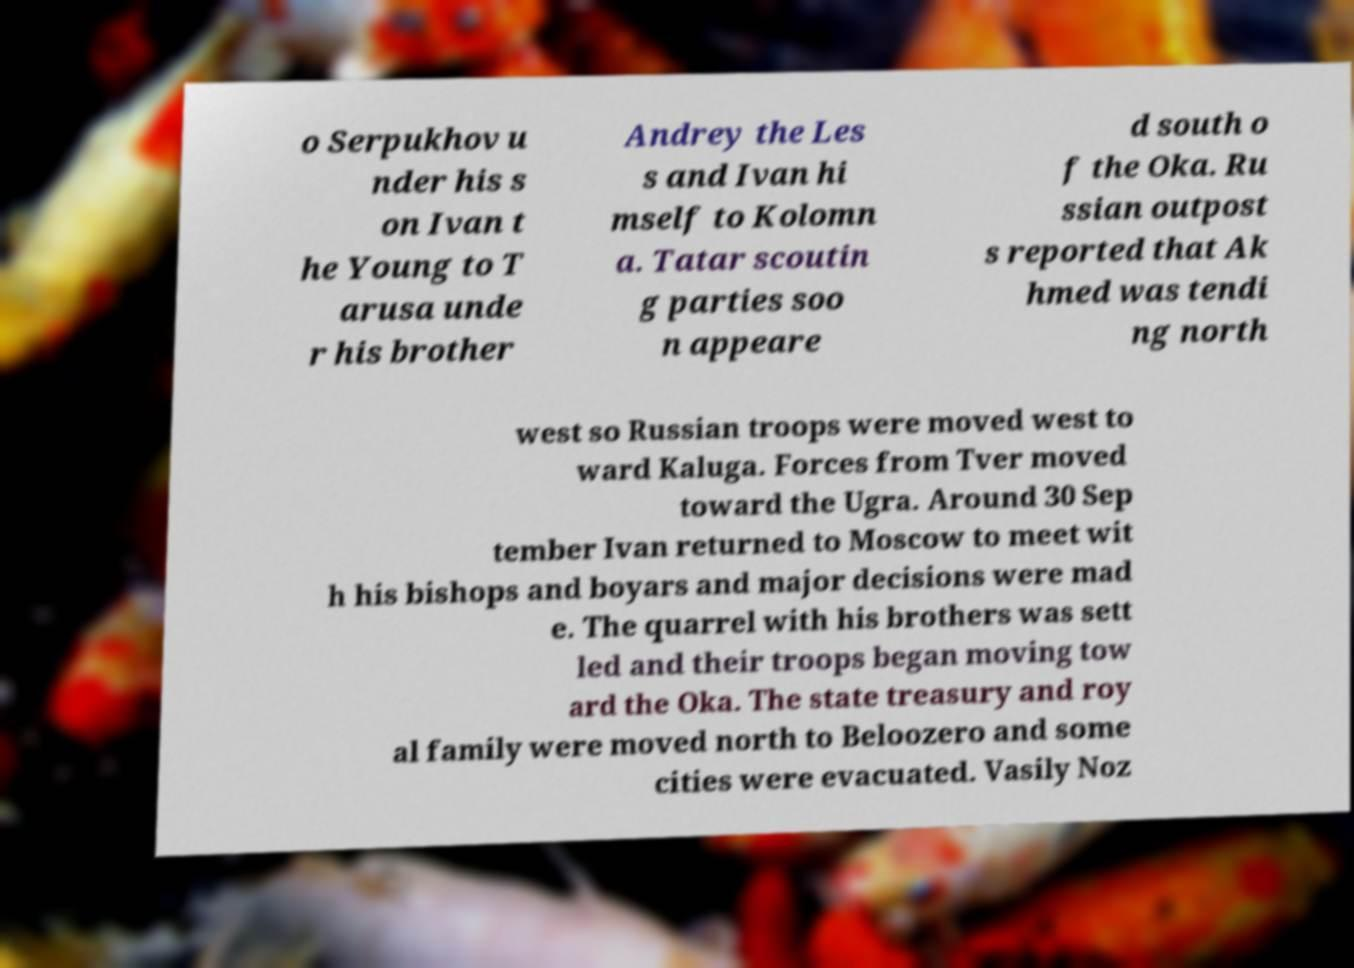Can you read and provide the text displayed in the image?This photo seems to have some interesting text. Can you extract and type it out for me? o Serpukhov u nder his s on Ivan t he Young to T arusa unde r his brother Andrey the Les s and Ivan hi mself to Kolomn a. Tatar scoutin g parties soo n appeare d south o f the Oka. Ru ssian outpost s reported that Ak hmed was tendi ng north west so Russian troops were moved west to ward Kaluga. Forces from Tver moved toward the Ugra. Around 30 Sep tember Ivan returned to Moscow to meet wit h his bishops and boyars and major decisions were mad e. The quarrel with his brothers was sett led and their troops began moving tow ard the Oka. The state treasury and roy al family were moved north to Beloozero and some cities were evacuated. Vasily Noz 